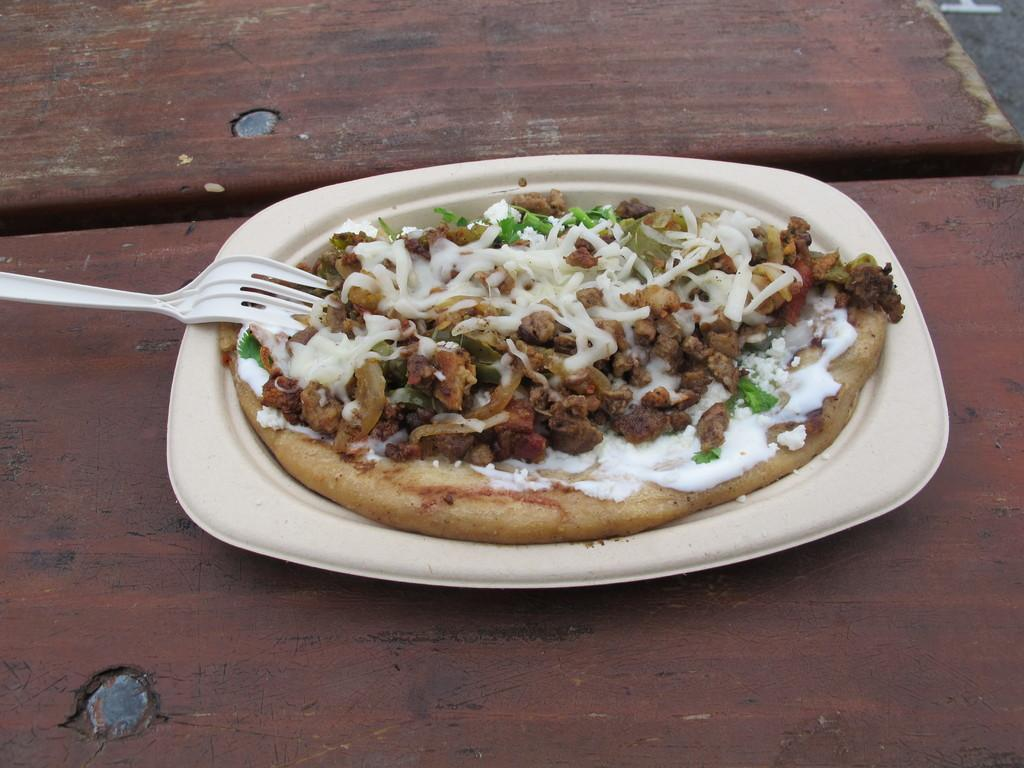What type of food is visible in the image? There is a pizza in the image. What utensil is present in the image? There is a fork in the image. How are the pizza and fork arranged in the image? The pizza and fork are in a plate. What type of butter is spread on the pizza in the image? There is no butter present on the pizza in the image. 